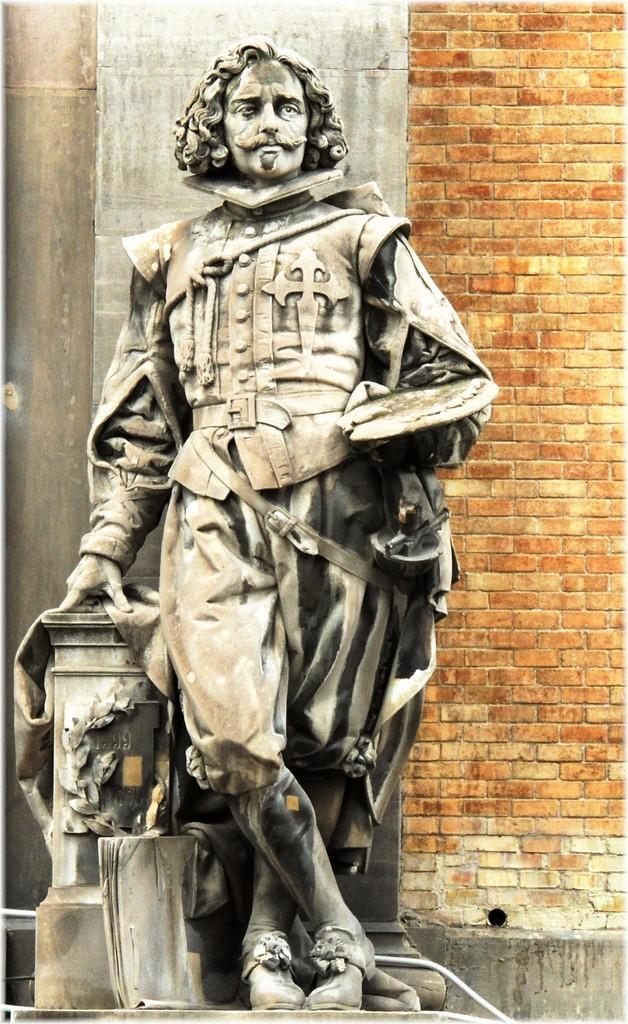What is the main subject in the image? There is a statue in the image. What can be seen in the background of the image? There is a wall visible in the background of the image. How many dinosaurs are sitting on the cushion next to the statue in the image? There are no dinosaurs or cushions present in the image. 